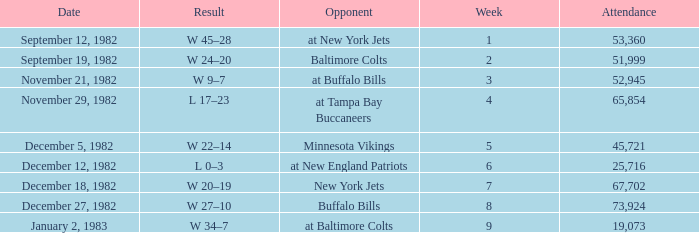What is the result of the game with an attendance greater than 67,702? W 27–10. 